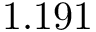<formula> <loc_0><loc_0><loc_500><loc_500>1 . 1 9 1</formula> 